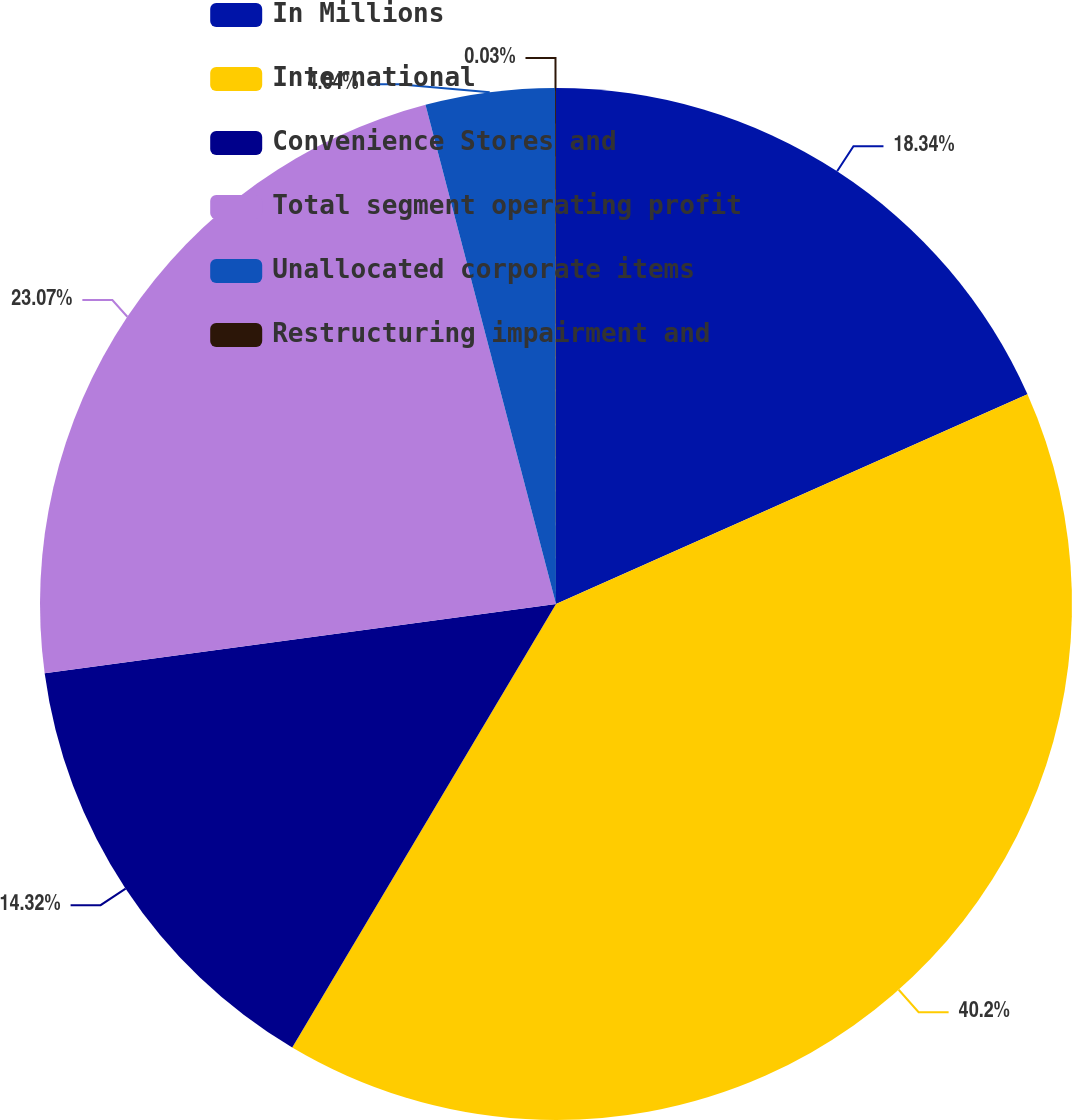Convert chart to OTSL. <chart><loc_0><loc_0><loc_500><loc_500><pie_chart><fcel>In Millions<fcel>International<fcel>Convenience Stores and<fcel>Total segment operating profit<fcel>Unallocated corporate items<fcel>Restructuring impairment and<nl><fcel>18.34%<fcel>40.2%<fcel>14.32%<fcel>23.07%<fcel>4.04%<fcel>0.03%<nl></chart> 